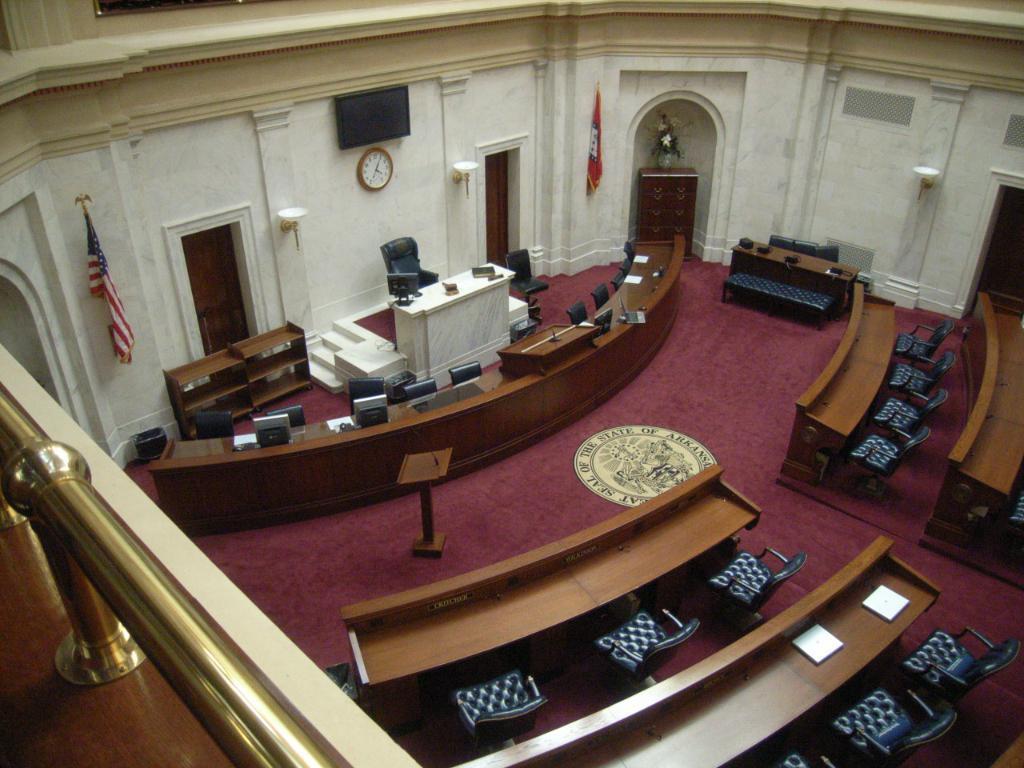How would you summarize this image in a sentence or two? In this picture I can see there is a table and chairs are assembled here and there is another chair and table. On the wall there are two flags, and there is a watch and a television screen. 